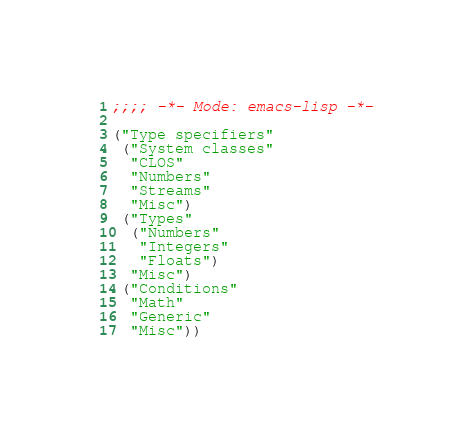<code> <loc_0><loc_0><loc_500><loc_500><_Lisp_>;;;; -*- Mode: emacs-lisp -*-

("Type specifiers"
 ("System classes"
  "CLOS"
  "Numbers"
  "Streams"
  "Misc")
 ("Types"
  ("Numbers"
   "Integers"
   "Floats")
  "Misc")
 ("Conditions"
  "Math"
  "Generic"
  "Misc"))
</code> 